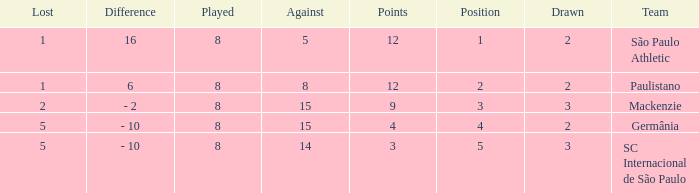What was the position with the total number less than 1? 0.0. 